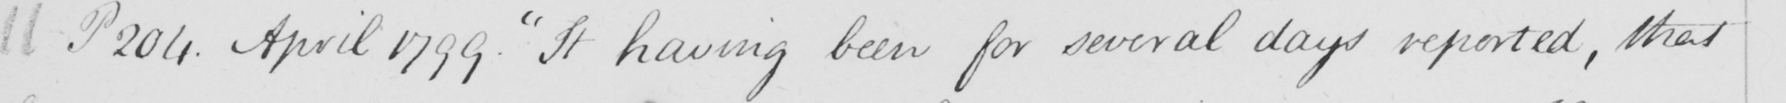Can you tell me what this handwritten text says? 11 P 204 . April 1799 .  " It having been for several days reported , that 